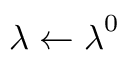<formula> <loc_0><loc_0><loc_500><loc_500>\lambda \leftarrow \lambda ^ { 0 }</formula> 